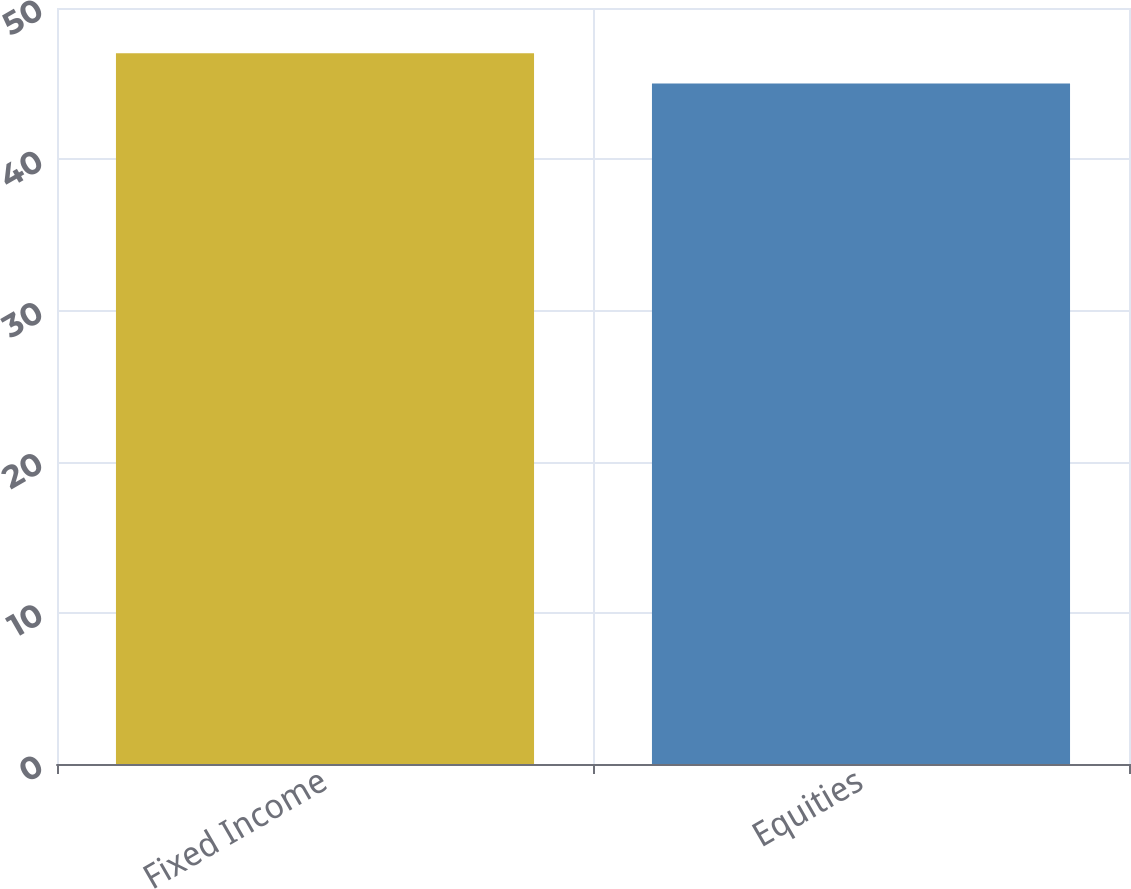<chart> <loc_0><loc_0><loc_500><loc_500><bar_chart><fcel>Fixed Income<fcel>Equities<nl><fcel>47<fcel>45<nl></chart> 